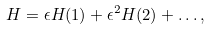Convert formula to latex. <formula><loc_0><loc_0><loc_500><loc_500>H = \epsilon H ( 1 ) + \epsilon ^ { 2 } H ( 2 ) + \dots ,</formula> 